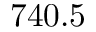Convert formula to latex. <formula><loc_0><loc_0><loc_500><loc_500>7 4 0 . 5</formula> 